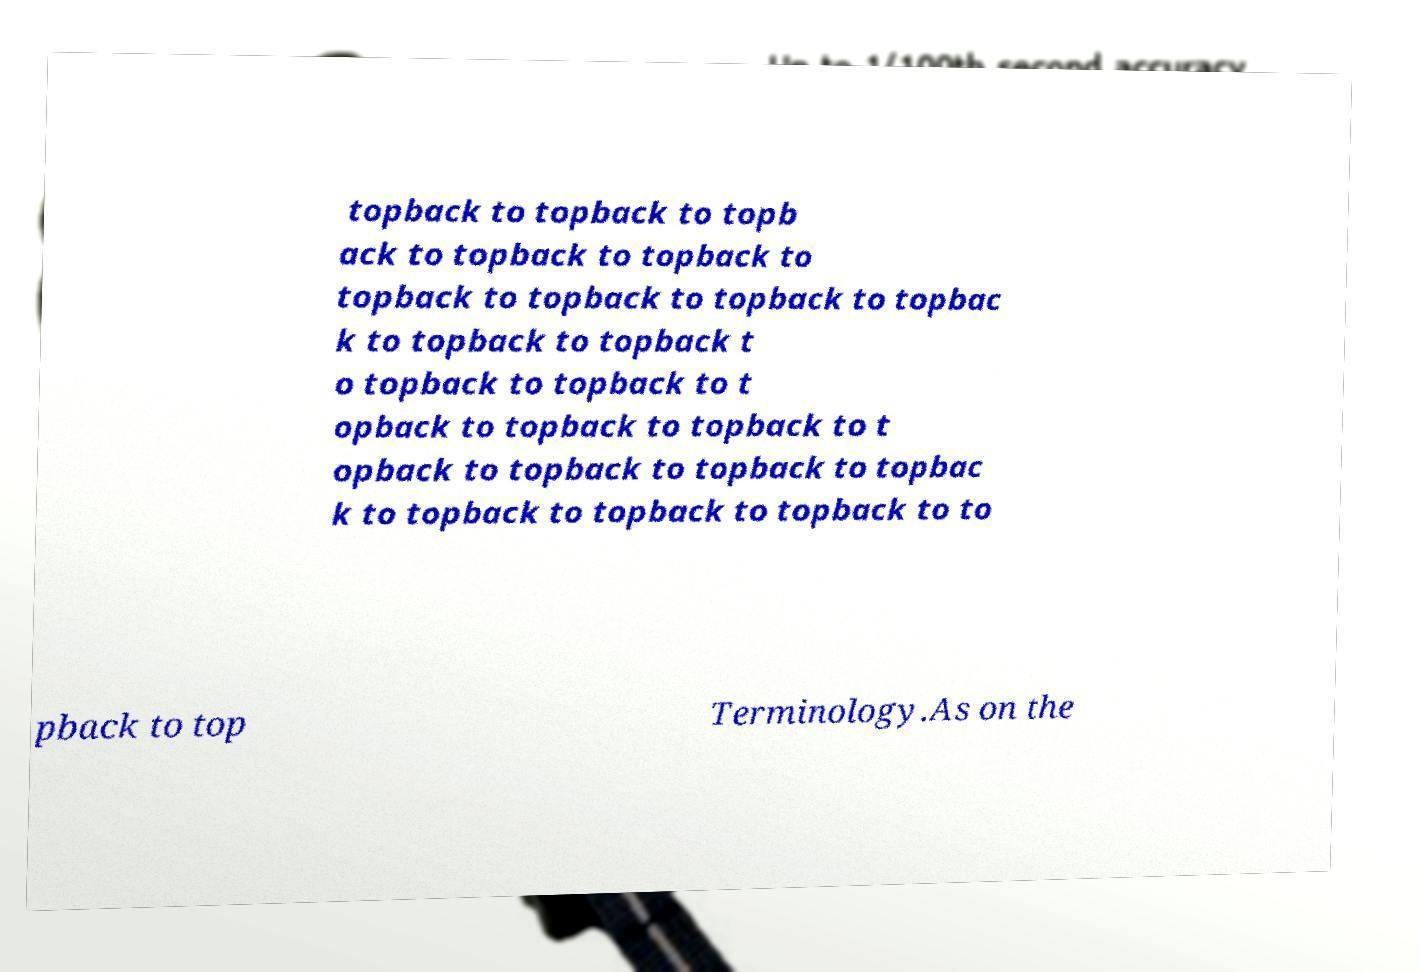Please read and relay the text visible in this image. What does it say? topback to topback to topb ack to topback to topback to topback to topback to topback to topbac k to topback to topback t o topback to topback to t opback to topback to topback to t opback to topback to topback to topbac k to topback to topback to topback to to pback to top Terminology.As on the 